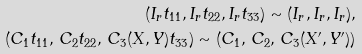Convert formula to latex. <formula><loc_0><loc_0><loc_500><loc_500>( I _ { r } t _ { 1 1 } , I _ { r } t _ { 2 2 } , I _ { r } t _ { 3 3 } ) \sim ( I _ { r } , I _ { r } , I _ { r } ) , \\ ( C _ { 1 } t _ { 1 1 } , \, C _ { 2 } t _ { 2 2 } , \, C _ { 3 } ( X , Y ) t _ { 3 3 } ) \sim ( C _ { 1 } , \, C _ { 2 } , \, C _ { 3 } ( X ^ { \prime } , Y ^ { \prime } ) )</formula> 